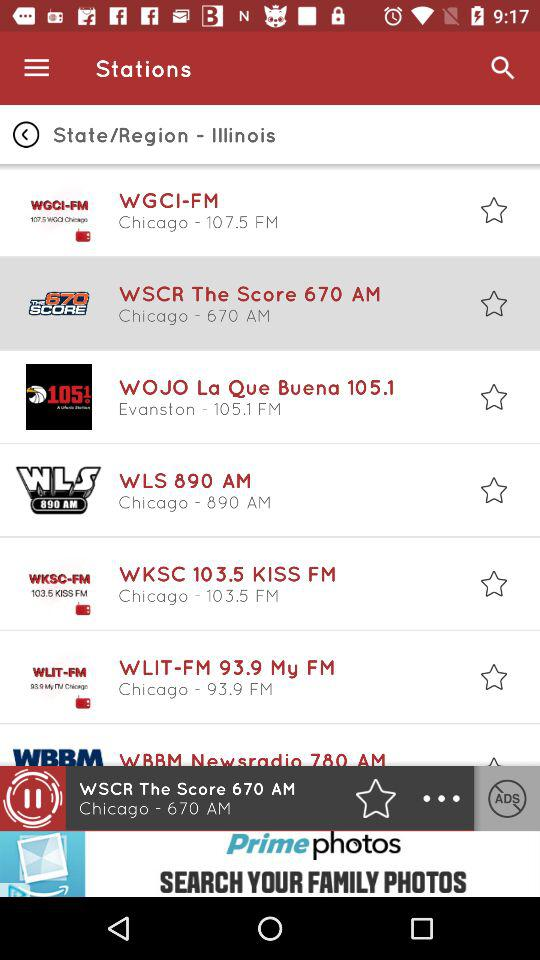What is the region of "WGCI-FM"? The region is Chicago. 